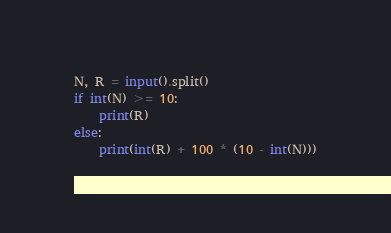Convert code to text. <code><loc_0><loc_0><loc_500><loc_500><_Python_>N, R = input().split()
if int(N) >= 10:
    print(R)
else:
    print(int(R) + 100 * (10 - int(N)))
</code> 